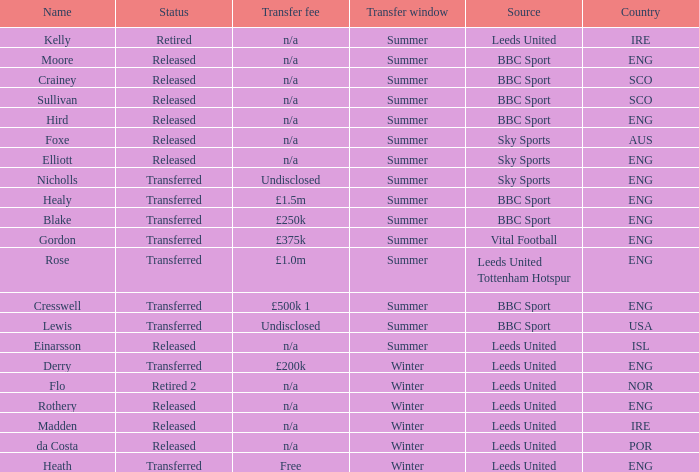What is the person's name that is from the country of SCO? Crainey, Sullivan. 